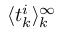Convert formula to latex. <formula><loc_0><loc_0><loc_500><loc_500>\langle t _ { k } ^ { i } \rangle _ { k } ^ { \infty }</formula> 